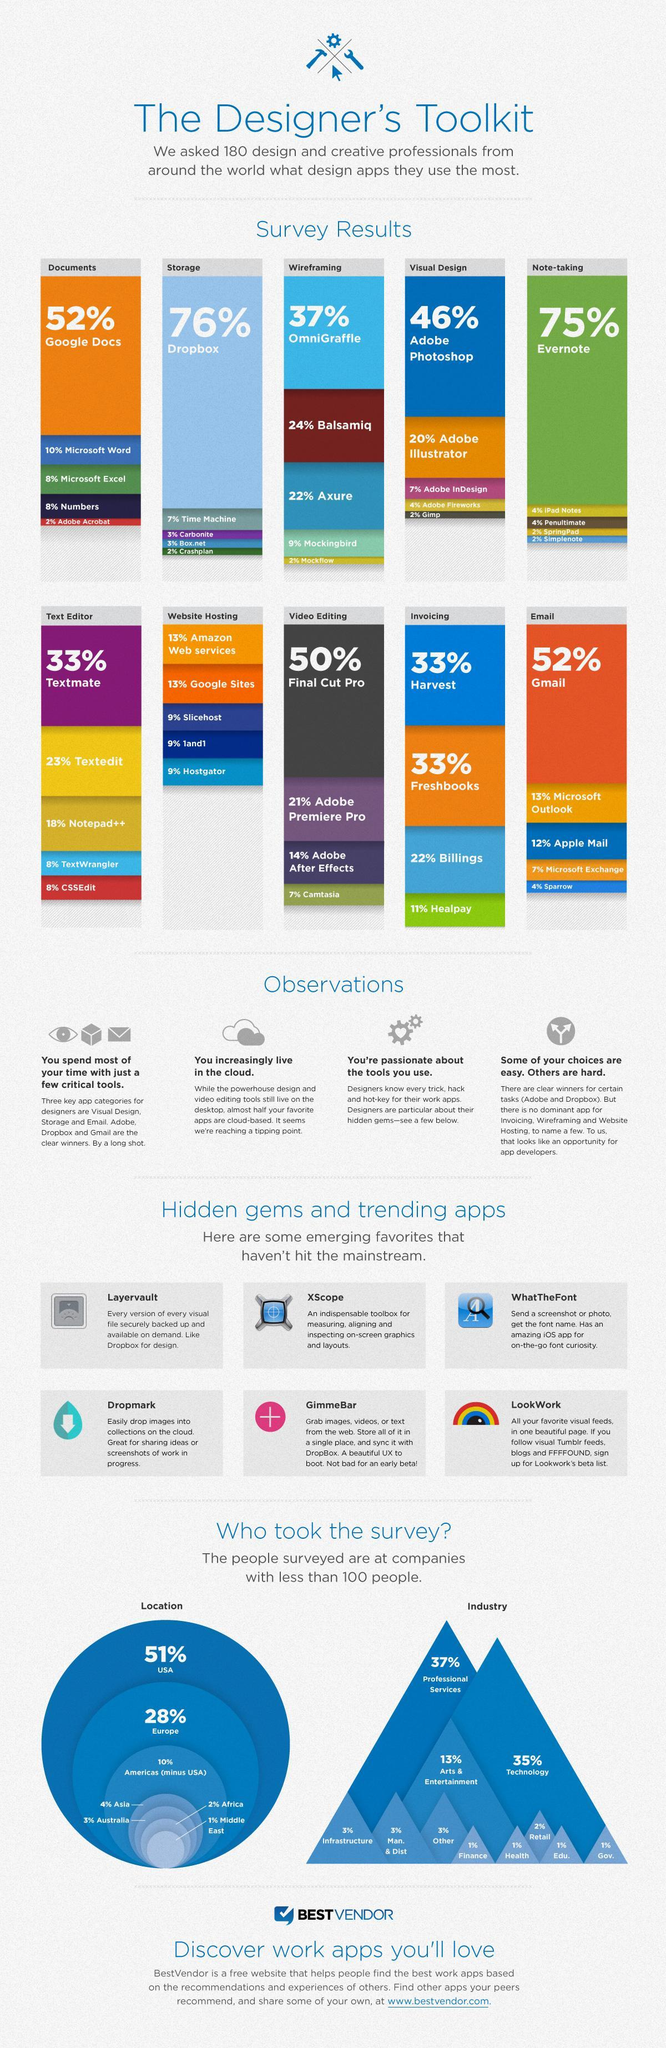Which are the two most popular apps used for invoicing?
Answer the question with a short phrase. Harvest, Freshbooks What percentage of designers use Carbonite and Box.net for storage? 3% Which app is used by a very low percentage of designers for storing? Crashplan From how many industries have 1% designers participated in the survey? 4 Which is the second most used app for visual designing, Illustrator, Photoshop, or InDesign? Illustrator What percentage of designers use Penultimate and iPad notes for note taking? 4% What percentage of designers use Slicehost, 1and1, or Hostgator for web hosting? 9% Which is the most prominently app to create documents ? Google Docs What is the percentage of designers using Adobe Acrobat, Mock Flow, or Gimp? 2% What percentage of designers have taken designer toolkit survey from infrastructure, manufacturing and other industries? 3% 